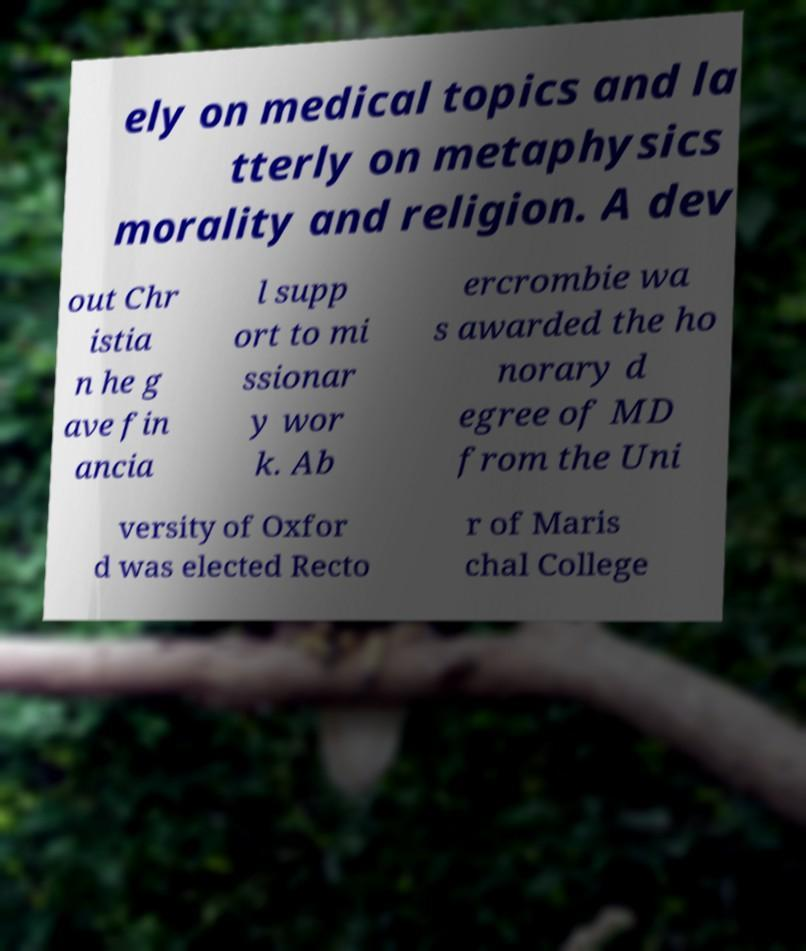For documentation purposes, I need the text within this image transcribed. Could you provide that? ely on medical topics and la tterly on metaphysics morality and religion. A dev out Chr istia n he g ave fin ancia l supp ort to mi ssionar y wor k. Ab ercrombie wa s awarded the ho norary d egree of MD from the Uni versity of Oxfor d was elected Recto r of Maris chal College 